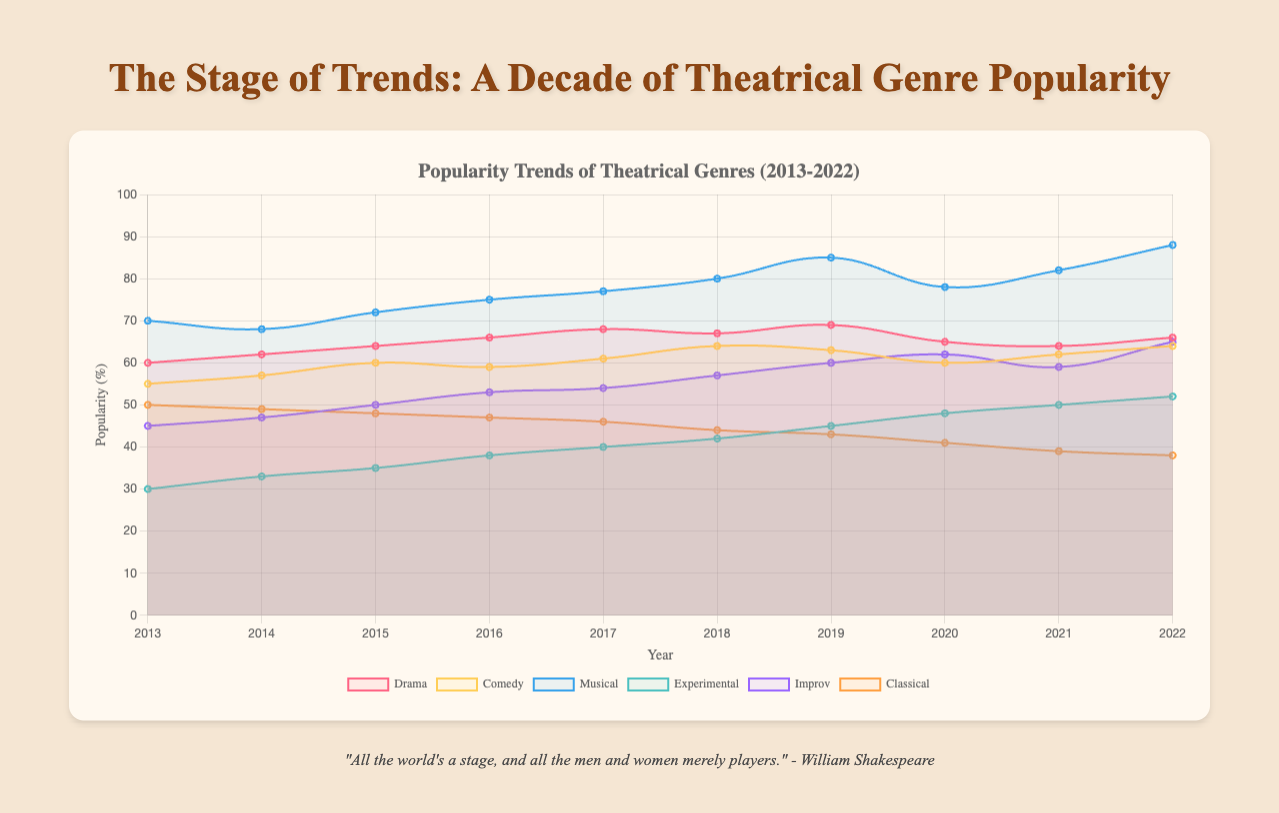Which theatrical genre experienced the highest increase in popularity from 2013 to 2022? To determine which genre experienced the highest increase, look at the popularity values for each genre in 2013 and 2022 and subtract the 2013 values from the 2022 values. The genre with the largest positive difference is the one with the highest increase. Examining the data, the musical genre increased from 70 in 2013 to 88 in 2022, an increase of 18, which is the largest among all genres.
Answer: Musical Which year shows the highest overall popularity for the comedy genre? To find the year with the highest overall popularity for comedy, refer to the popularity values for each year and identify the maximum value. The peak value for comedy is 64, which happens in both 2018 and 2022. Thus, these are the years with the highest popularity for comedy.
Answer: 2018 and 2022 Did the improv genre ever surpass the drama genre in popularity between 2013 and 2022? To check if the improv genre surpassed the drama genre, compare the yearly popularity values of both genres side by side. The improv genre's highest value is 65 in 2022, while the drama genre's lowest is 60 in 2013. At no point did improv exceed drama. Thus, improv never surpassed drama in popularity.
Answer: No How did the popularity of the experimental genre change from 2013 to 2016? Observe the popularity values for the experimental genre from 2013 to 2016. In 2013, its value is 30; in 2014, 33; in 2015, 35; and 2016, 38. The experimental genre consistently increased its popularity every year within this range.
Answer: It increased What is the average popularity of the classical genre over the decade from 2013 to 2022? To calculate the average popularity of the classical genre over the decade, sum all values from 2013 to 2022 and then divide by the number of years. The values are 50, 49, 48, 47, 46, 44, 43, 41, 39, and 38. Summing these gives 445, and dividing by 10 years results in an average of 44.5.
Answer: 44.5 Which genre had the smallest range in popularity values over the decade? The range is calculated by subtracting the smallest value from the largest value for each genre. Drama ranges from 60 to 69 (range 9), comedy from 55 to 64 (range 9), musical from 68 to 88 (range 20), experimental from 30 to 52 (range 22), improv from 45 to 65 (range 20), and classical from 38 to 50 (range 12). Comedy and drama both have the smallest range of 9.
Answer: Drama and Comedy Which genre portrayed the most fluctuation in its popularity, judging by the number of peaks and troughs in its trend line? By visually inspecting the trend lines, count the number of peaks (local maxima) and troughs (local minima). The experimental genre shows the most significant fluctuations with multiple peaks and troughs compared to relatively smooth trends in other genres.
Answer: Experimental Compare the popularity trends of drama and musicals. Which one had a greater overall increase or decrease from 2013 to 2022? Comparing the initial and final values for both genres, drama increases from 60 to 66 (6 points), and musical increases from 70 to 88 (18 points). Thus, musicals saw a greater overall increase in popularity.
Answer: Musical When did the musical genre start being significantly more popular than the classical genre? Trace when the difference between musical and classical genres began to be notably large. In 2013, musical is at 70 and classical at 50 (difference of 20). Each subsequent year, the gap generally widens with a significant difference noticed as early as 2013 and onward with musical always having significantly higher values.
Answer: 2013 What is the trend of the experimental genre from 2019 to 2022? Look at the values from 2019 to 2022 for the experimental genre: 45, 48, 50, 52. There is a consistent upward trend in these values each year, indicating increasing popularity.
Answer: Increasing 